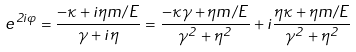Convert formula to latex. <formula><loc_0><loc_0><loc_500><loc_500>e ^ { 2 i \varphi } = \frac { - \kappa + i \eta m / E } { \gamma + i \eta } = \frac { - \kappa \gamma + \eta m / E } { \gamma ^ { 2 } + \eta ^ { 2 } } + i \frac { \eta \kappa + \eta m / E } { \gamma ^ { 2 } + \eta ^ { 2 } }</formula> 